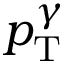Convert formula to latex. <formula><loc_0><loc_0><loc_500><loc_500>p _ { T } ^ { \gamma }</formula> 